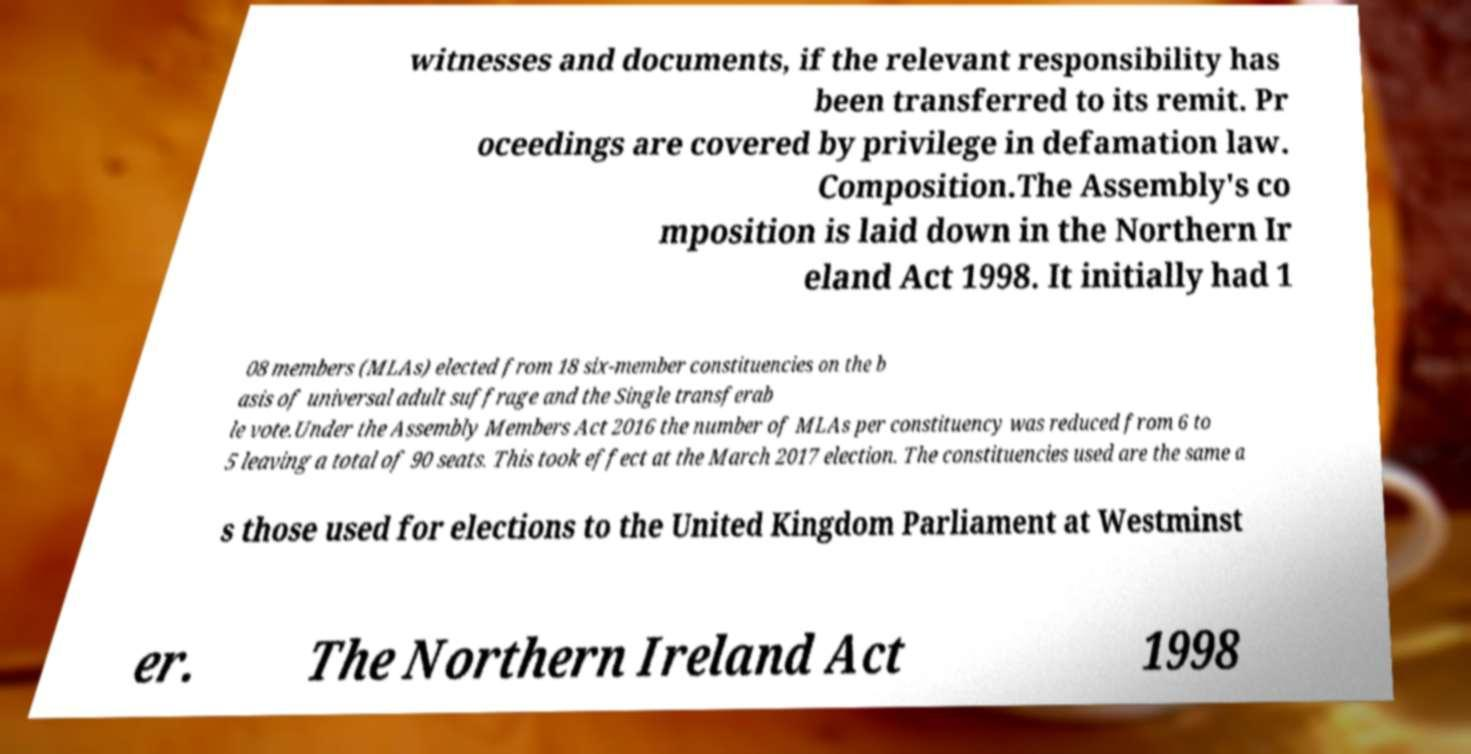Please read and relay the text visible in this image. What does it say? witnesses and documents, if the relevant responsibility has been transferred to its remit. Pr oceedings are covered by privilege in defamation law. Composition.The Assembly's co mposition is laid down in the Northern Ir eland Act 1998. It initially had 1 08 members (MLAs) elected from 18 six-member constituencies on the b asis of universal adult suffrage and the Single transferab le vote.Under the Assembly Members Act 2016 the number of MLAs per constituency was reduced from 6 to 5 leaving a total of 90 seats. This took effect at the March 2017 election. The constituencies used are the same a s those used for elections to the United Kingdom Parliament at Westminst er. The Northern Ireland Act 1998 